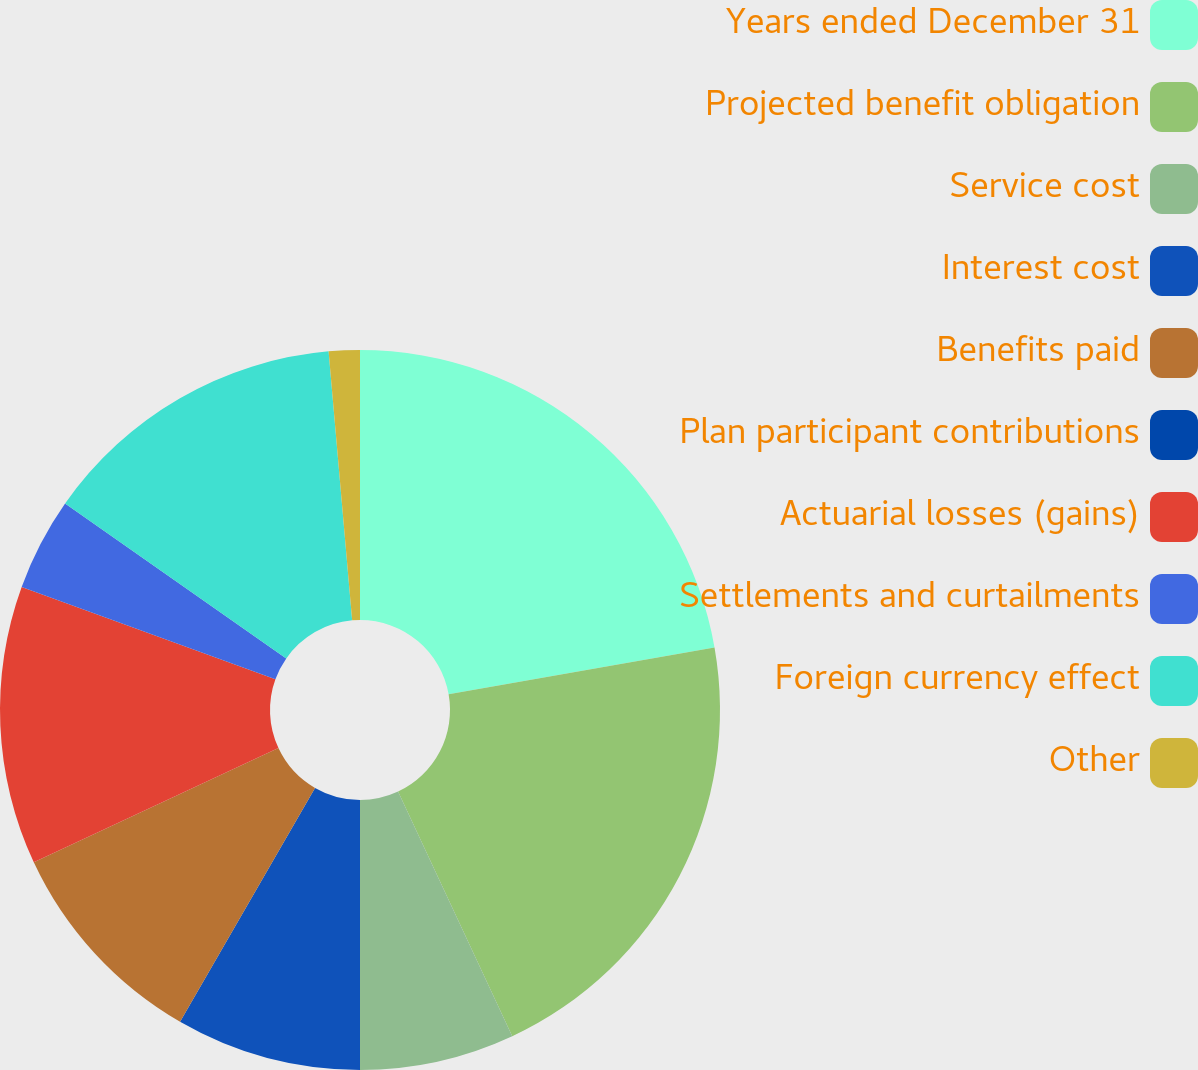Convert chart. <chart><loc_0><loc_0><loc_500><loc_500><pie_chart><fcel>Years ended December 31<fcel>Projected benefit obligation<fcel>Service cost<fcel>Interest cost<fcel>Benefits paid<fcel>Plan participant contributions<fcel>Actuarial losses (gains)<fcel>Settlements and curtailments<fcel>Foreign currency effect<fcel>Other<nl><fcel>22.22%<fcel>20.83%<fcel>6.95%<fcel>8.33%<fcel>9.72%<fcel>0.0%<fcel>12.5%<fcel>4.17%<fcel>13.89%<fcel>1.39%<nl></chart> 